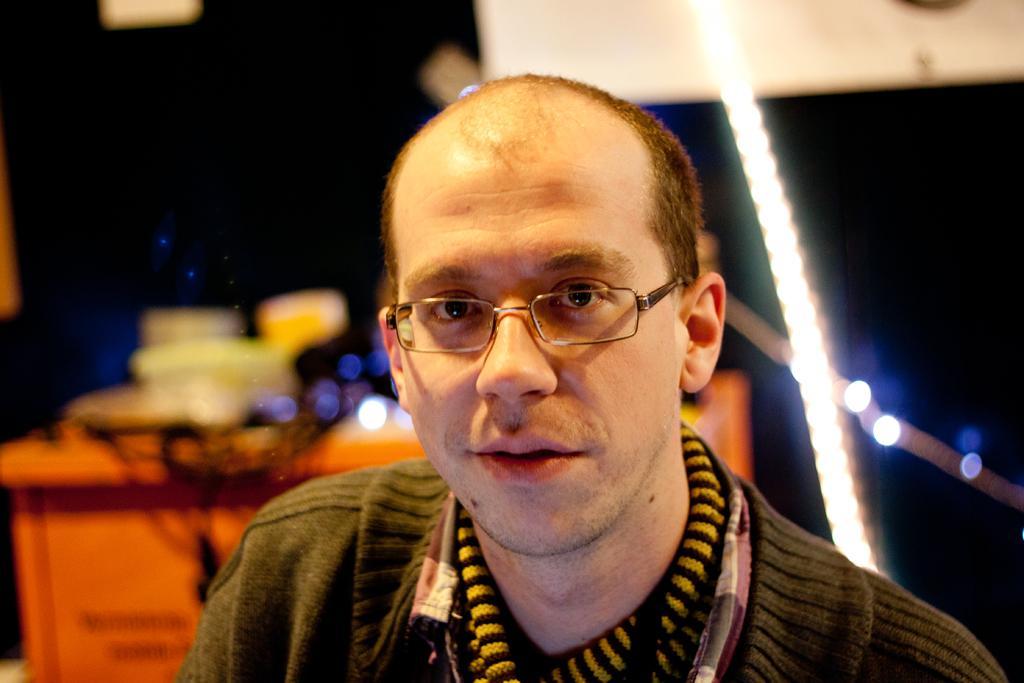In one or two sentences, can you explain what this image depicts? In this image I can see the person with yellow, black and grey color dress. The person is wearing the specs. In the background I can see some objects on the table many lights but it is blurry. 